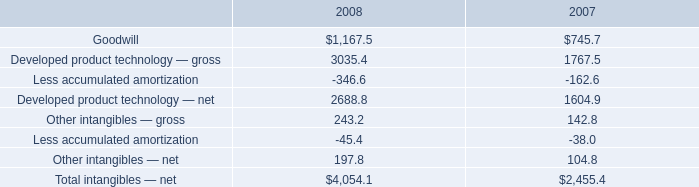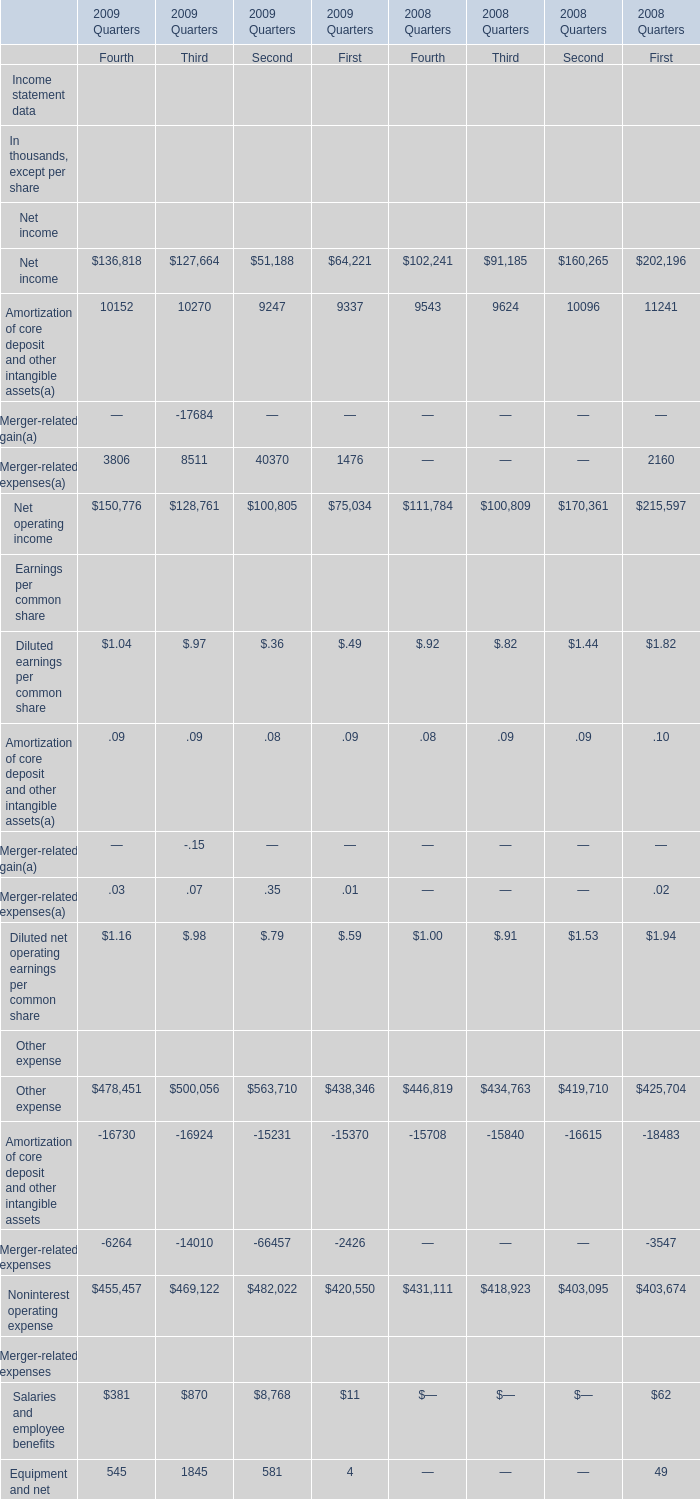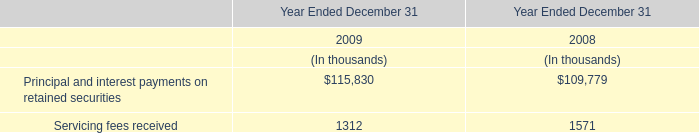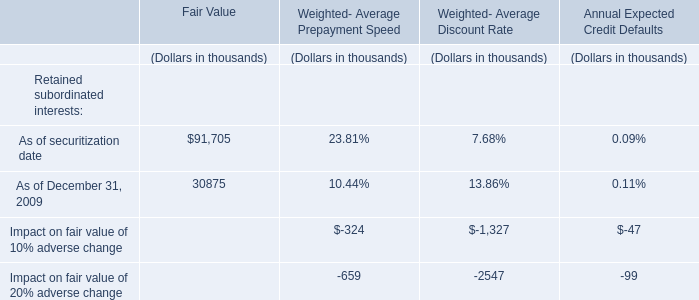What is the growing rate of Diluted earnings per common share in the years with the least Merger-related expenses(a)?? 
Computations: (((((1.04 + 0.97) + 0.36) + 0.49) - (((0.92 + 0.82) + 1.44) + 1.82)) / (((1.04 + 0.97) + 0.36) + 0.49))
Answer: -0.74825. 